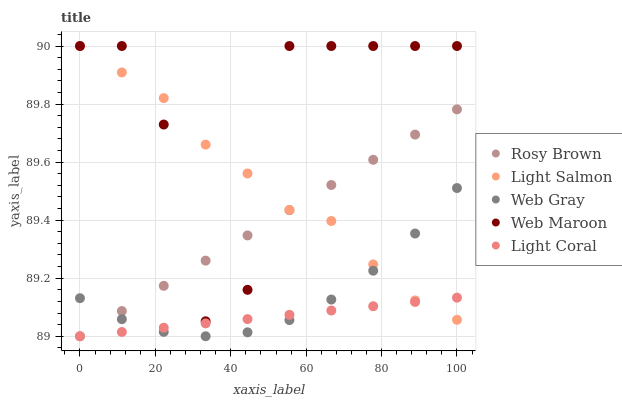Does Light Coral have the minimum area under the curve?
Answer yes or no. Yes. Does Web Maroon have the maximum area under the curve?
Answer yes or no. Yes. Does Light Salmon have the minimum area under the curve?
Answer yes or no. No. Does Light Salmon have the maximum area under the curve?
Answer yes or no. No. Is Light Coral the smoothest?
Answer yes or no. Yes. Is Web Maroon the roughest?
Answer yes or no. Yes. Is Light Salmon the smoothest?
Answer yes or no. No. Is Light Salmon the roughest?
Answer yes or no. No. Does Light Coral have the lowest value?
Answer yes or no. Yes. Does Web Maroon have the lowest value?
Answer yes or no. No. Does Light Salmon have the highest value?
Answer yes or no. Yes. Does Rosy Brown have the highest value?
Answer yes or no. No. Is Light Coral less than Web Maroon?
Answer yes or no. Yes. Is Web Maroon greater than Light Coral?
Answer yes or no. Yes. Does Web Maroon intersect Light Salmon?
Answer yes or no. Yes. Is Web Maroon less than Light Salmon?
Answer yes or no. No. Is Web Maroon greater than Light Salmon?
Answer yes or no. No. Does Light Coral intersect Web Maroon?
Answer yes or no. No. 